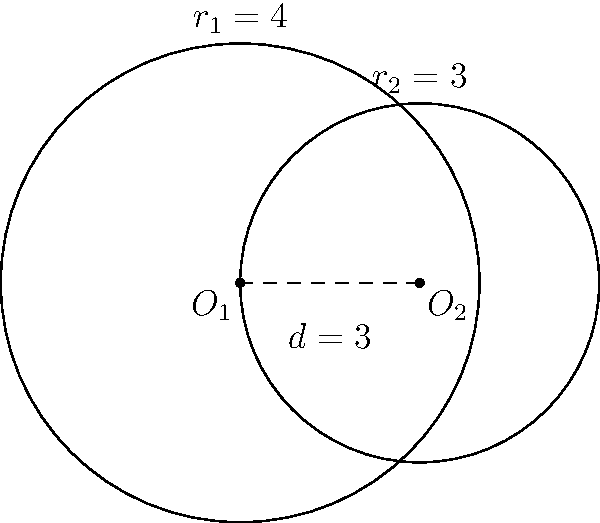Given two circles with centers $O_1(0,0)$ and $O_2(3,0)$, and radii $r_1 = 4$ and $r_2 = 3$ respectively, calculate the area of the overlapping region. Provide a detailed explanation of your approach, including any relevant formulas and intermediate steps. How might this problem be relevant in the context of computer graphics or user interface design in Android development? Let's approach this step-by-step:

1) First, we need to determine if the circles intersect. The distance between the centers is $d = 3$, and $r_1 + r_2 = 7 > d$, so they do intersect.

2) The area of overlap can be calculated using the formula:

   $$A = r_1^2 \arccos(\frac{d^2 + r_1^2 - r_2^2}{2dr_1}) + r_2^2 \arccos(\frac{d^2 + r_2^2 - r_1^2}{2dr_2}) - \frac{1}{2}\sqrt{(-d+r_1+r_2)(d+r_1-r_2)(d-r_1+r_2)(d+r_1+r_2)}$$

3) Let's substitute our values:
   $r_1 = 4$, $r_2 = 3$, $d = 3$

4) Calculating each part:
   
   Part 1: $4^2 \arccos(\frac{3^2 + 4^2 - 3^2}{2 \cdot 3 \cdot 4}) = 16 \arccos(\frac{25}{24}) \approx 16 \cdot 0.2731 = 4.3696$
   
   Part 2: $3^2 \arccos(\frac{3^2 + 3^2 - 4^2}{2 \cdot 3 \cdot 3}) = 9 \arccos(\frac{2}{9}) \approx 9 \cdot 1.3694 = 12.3246$
   
   Part 3: $-\frac{1}{2}\sqrt{(-3+4+3)(3+4-3)(3-4+3)(3+4+3)} = -\frac{1}{2}\sqrt{4 \cdot 4 \cdot 2 \cdot 10} = -\sqrt{160} = -12.6491$

5) Adding these parts:
   $A = 4.3696 + 12.3246 - 12.6491 = 4.0451$

Therefore, the area of overlap is approximately 4.0451 square units.

In the context of Android development, this problem could be relevant for:
1) Designing overlapping UI elements, such as buttons or icons.
2) Implementing collision detection in 2D games.
3) Creating custom view animations where elements intersect.
4) Optimizing layout calculations for overlapping views.
5) Implementing drawing functions for custom views that involve circular shapes.
Answer: 4.0451 square units 